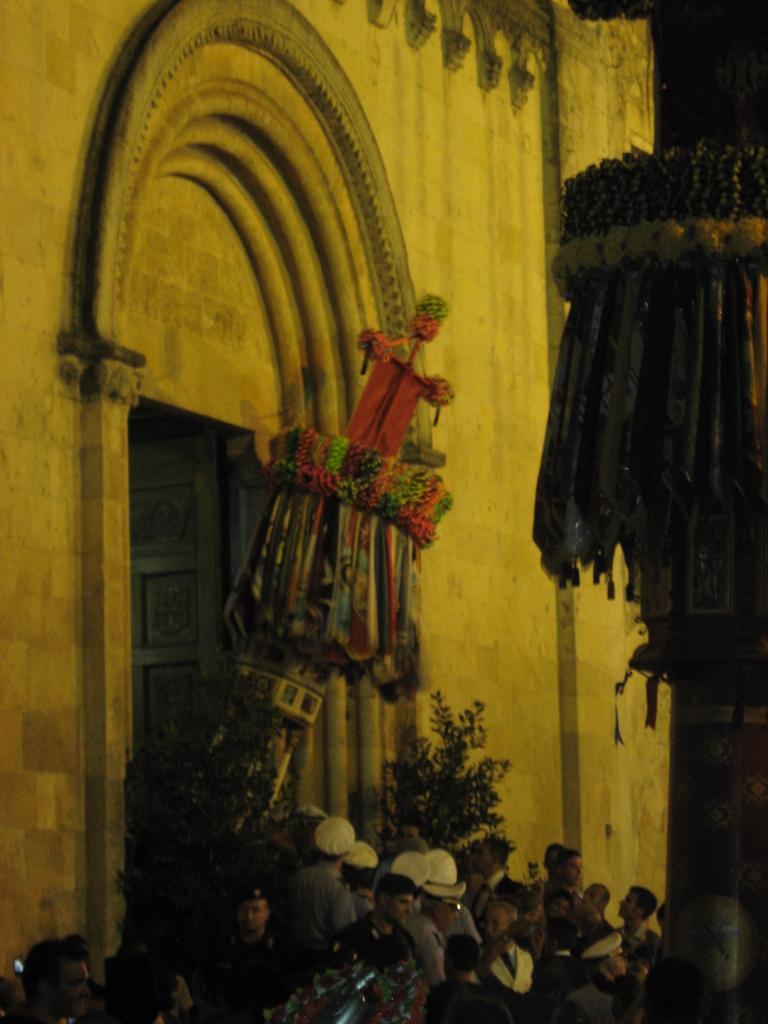Could you give a brief overview of what you see in this image? At the bottom of the picture, we see people are standing. Behind them, we see flower pots. Behind that, we see a wall in white color. In the middle of the picture, we see something in orange, green and brown color. On the right side, we see a pillar. 